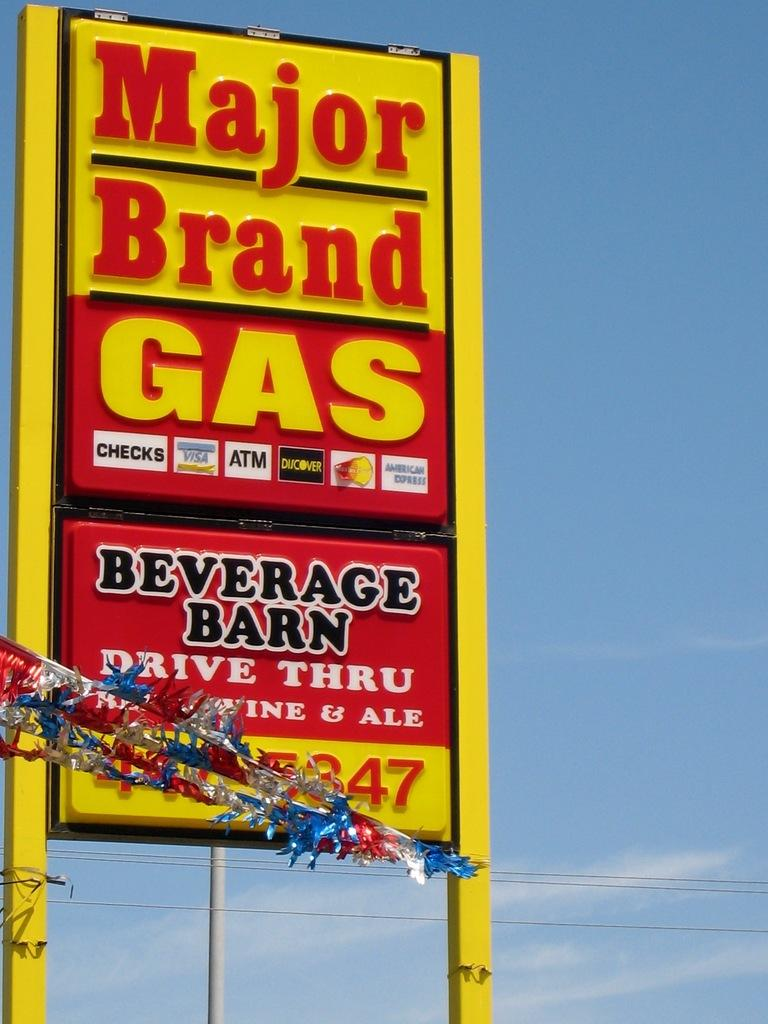Provide a one-sentence caption for the provided image. A large yellow and red sign for Major brand Gas and Beverage Barn. 